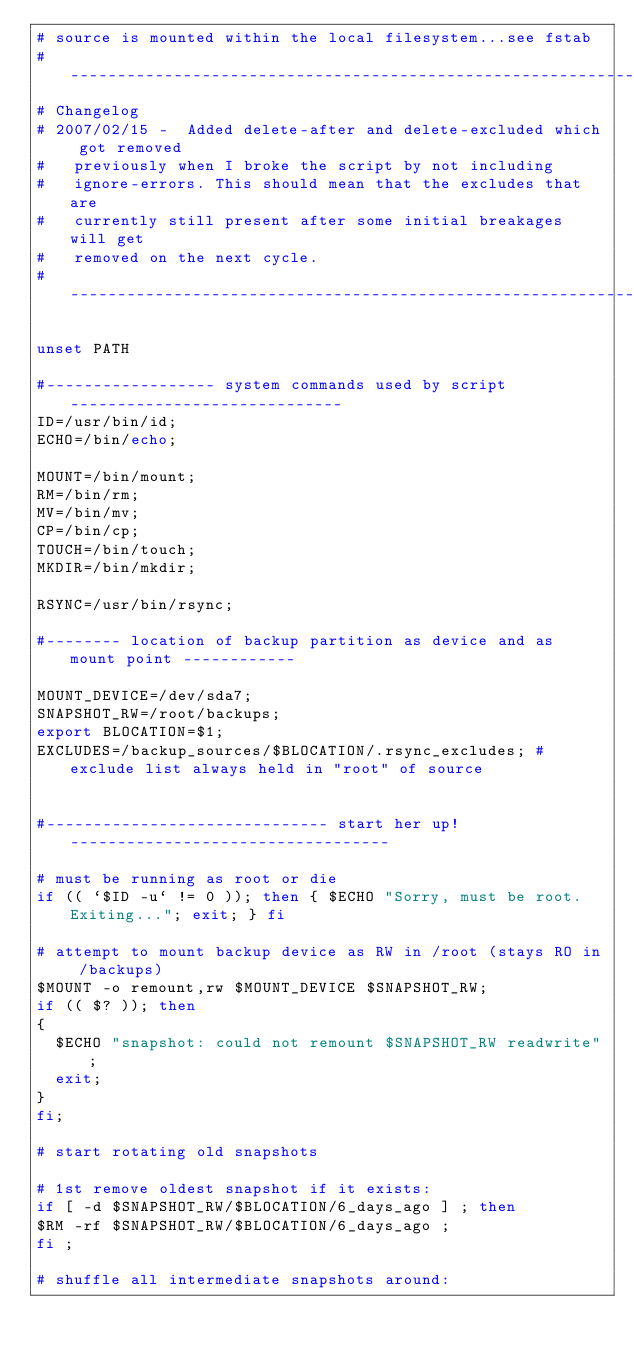Convert code to text. <code><loc_0><loc_0><loc_500><loc_500><_Bash_># source is mounted within the local filesystem...see fstab
#-------------------------------------------------------------------------------
# Changelog
# 2007/02/15 -	Added delete-after and delete-excluded which got removed
#		previously when I broke the script by not including
#		ignore-errors. This should mean that the excludes that are
#		currently still present after some initial breakages will get
#		removed on the next cycle.
#-------------------------------------------------------------------------------

unset PATH

#------------------ system commands used by script -----------------------------
ID=/usr/bin/id;
ECHO=/bin/echo;

MOUNT=/bin/mount;
RM=/bin/rm;
MV=/bin/mv;
CP=/bin/cp;
TOUCH=/bin/touch;
MKDIR=/bin/mkdir;

RSYNC=/usr/bin/rsync;

#-------- location of backup partition as device and as mount point ------------

MOUNT_DEVICE=/dev/sda7;
SNAPSHOT_RW=/root/backups;
export BLOCATION=$1;
EXCLUDES=/backup_sources/$BLOCATION/.rsync_excludes; #exclude list always held in "root" of source 


#------------------------------ start her up! ----------------------------------

# must be running as root or die
if (( `$ID -u` != 0 )); then { $ECHO "Sorry, must be root. Exiting..."; exit; } fi

# attempt to mount backup device as RW in /root (stays RO in /backups)
$MOUNT -o remount,rw $MOUNT_DEVICE $SNAPSHOT_RW;
if (( $? )); then
{
	$ECHO "snapshot: could not remount $SNAPSHOT_RW readwrite";
	exit;
}
fi;

# start rotating old snapshots

# 1st remove oldest snapshot if it exists:
if [ -d $SNAPSHOT_RW/$BLOCATION/6_days_ago ] ; then
$RM -rf $SNAPSHOT_RW/$BLOCATION/6_days_ago ;
fi ;

# shuffle all intermediate snapshots around:</code> 